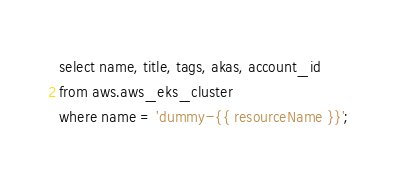<code> <loc_0><loc_0><loc_500><loc_500><_SQL_>select name, title, tags, akas, account_id
from aws.aws_eks_cluster
where name = 'dummy-{{ resourceName }}';</code> 